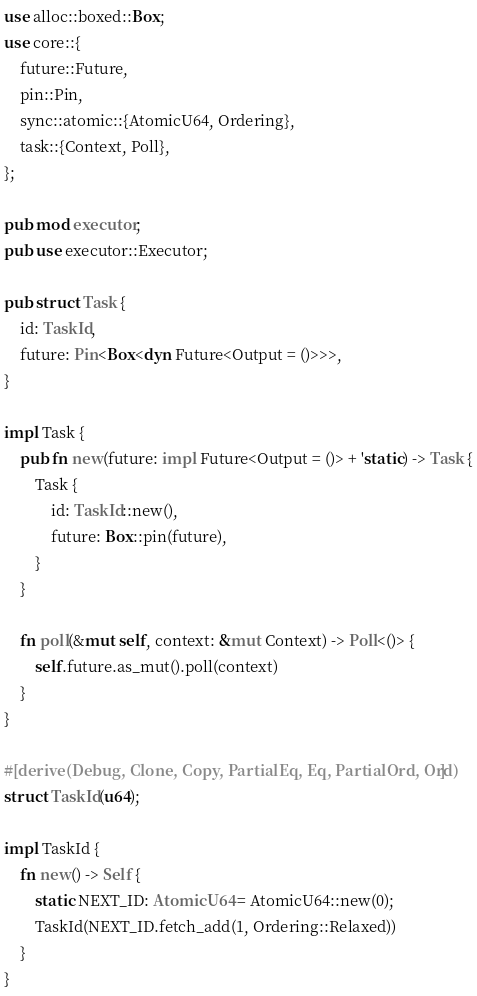Convert code to text. <code><loc_0><loc_0><loc_500><loc_500><_Rust_>use alloc::boxed::Box;
use core::{
    future::Future,
    pin::Pin,
    sync::atomic::{AtomicU64, Ordering},
    task::{Context, Poll},
};

pub mod executor;
pub use executor::Executor;

pub struct Task {
    id: TaskId,
    future: Pin<Box<dyn Future<Output = ()>>>,
}

impl Task {
    pub fn new(future: impl Future<Output = ()> + 'static) -> Task {
        Task {
            id: TaskId::new(),
            future: Box::pin(future),
        }
    }

    fn poll(&mut self, context: &mut Context) -> Poll<()> {
        self.future.as_mut().poll(context)
    }
}

#[derive(Debug, Clone, Copy, PartialEq, Eq, PartialOrd, Ord)]
struct TaskId(u64);

impl TaskId {
    fn new() -> Self {
        static NEXT_ID: AtomicU64 = AtomicU64::new(0);
        TaskId(NEXT_ID.fetch_add(1, Ordering::Relaxed))
    }
}
</code> 